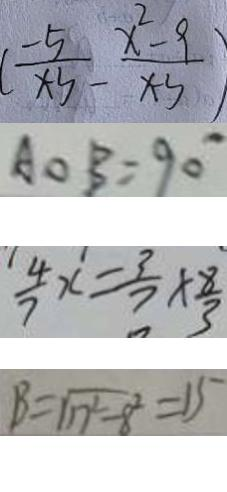<formula> <loc_0><loc_0><loc_500><loc_500>( \frac { - 5 } { x - 3 } - \frac { x ^ { 2 } - 9 } { x - 3 } ) 
 A O B = 9 0 ^ { \circ } 
 \frac { 4 } { 7 } x = \frac { 3 } { 7 } \times \frac { 8 } { 3 } 
 B = \sqrt { n ^ { 2 } - 8 ^ { 2 } } = 1 5</formula> 